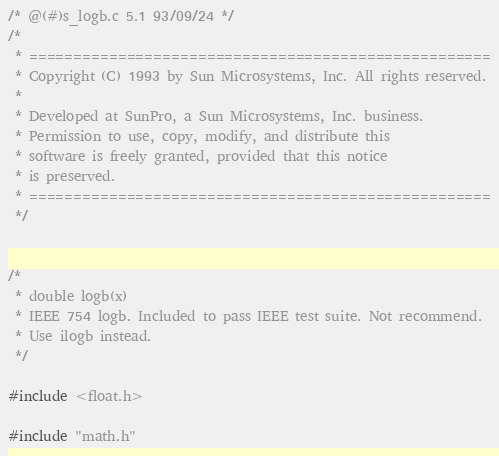Convert code to text. <code><loc_0><loc_0><loc_500><loc_500><_C_>/* @(#)s_logb.c 5.1 93/09/24 */
/*
 * ====================================================
 * Copyright (C) 1993 by Sun Microsystems, Inc. All rights reserved.
 *
 * Developed at SunPro, a Sun Microsystems, Inc. business.
 * Permission to use, copy, modify, and distribute this
 * software is freely granted, provided that this notice
 * is preserved.
 * ====================================================
 */


/*
 * double logb(x)
 * IEEE 754 logb. Included to pass IEEE test suite. Not recommend.
 * Use ilogb instead.
 */

#include <float.h>

#include "math.h"</code> 